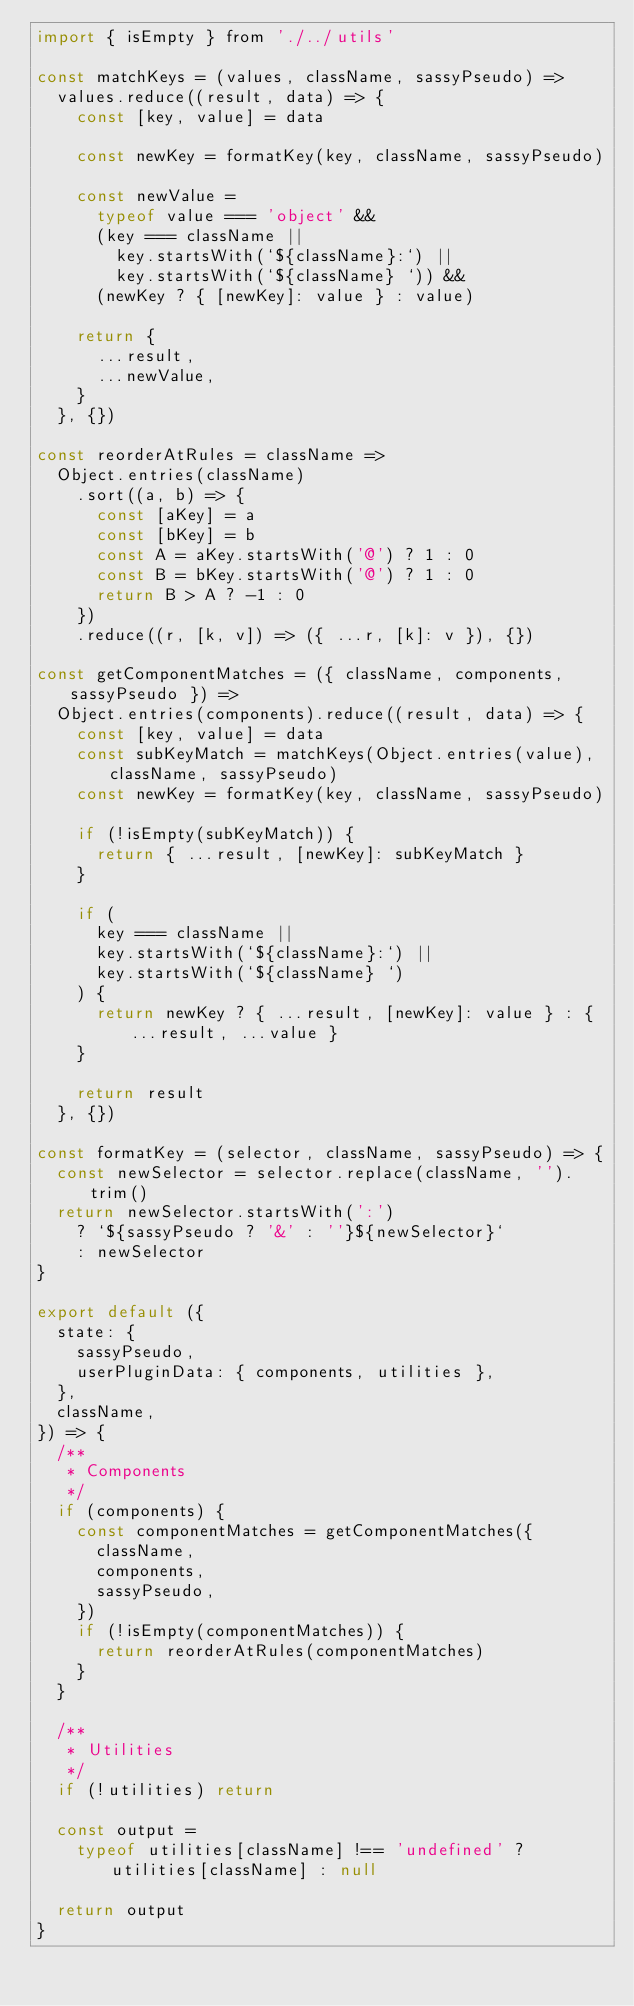Convert code to text. <code><loc_0><loc_0><loc_500><loc_500><_JavaScript_>import { isEmpty } from './../utils'

const matchKeys = (values, className, sassyPseudo) =>
  values.reduce((result, data) => {
    const [key, value] = data

    const newKey = formatKey(key, className, sassyPseudo)

    const newValue =
      typeof value === 'object' &&
      (key === className ||
        key.startsWith(`${className}:`) ||
        key.startsWith(`${className} `)) &&
      (newKey ? { [newKey]: value } : value)

    return {
      ...result,
      ...newValue,
    }
  }, {})

const reorderAtRules = className =>
  Object.entries(className)
    .sort((a, b) => {
      const [aKey] = a
      const [bKey] = b
      const A = aKey.startsWith('@') ? 1 : 0
      const B = bKey.startsWith('@') ? 1 : 0
      return B > A ? -1 : 0
    })
    .reduce((r, [k, v]) => ({ ...r, [k]: v }), {})

const getComponentMatches = ({ className, components, sassyPseudo }) =>
  Object.entries(components).reduce((result, data) => {
    const [key, value] = data
    const subKeyMatch = matchKeys(Object.entries(value), className, sassyPseudo)
    const newKey = formatKey(key, className, sassyPseudo)

    if (!isEmpty(subKeyMatch)) {
      return { ...result, [newKey]: subKeyMatch }
    }

    if (
      key === className ||
      key.startsWith(`${className}:`) ||
      key.startsWith(`${className} `)
    ) {
      return newKey ? { ...result, [newKey]: value } : { ...result, ...value }
    }

    return result
  }, {})

const formatKey = (selector, className, sassyPseudo) => {
  const newSelector = selector.replace(className, '').trim()
  return newSelector.startsWith(':')
    ? `${sassyPseudo ? '&' : ''}${newSelector}`
    : newSelector
}

export default ({
  state: {
    sassyPseudo,
    userPluginData: { components, utilities },
  },
  className,
}) => {
  /**
   * Components
   */
  if (components) {
    const componentMatches = getComponentMatches({
      className,
      components,
      sassyPseudo,
    })
    if (!isEmpty(componentMatches)) {
      return reorderAtRules(componentMatches)
    }
  }

  /**
   * Utilities
   */
  if (!utilities) return

  const output =
    typeof utilities[className] !== 'undefined' ? utilities[className] : null

  return output
}
</code> 